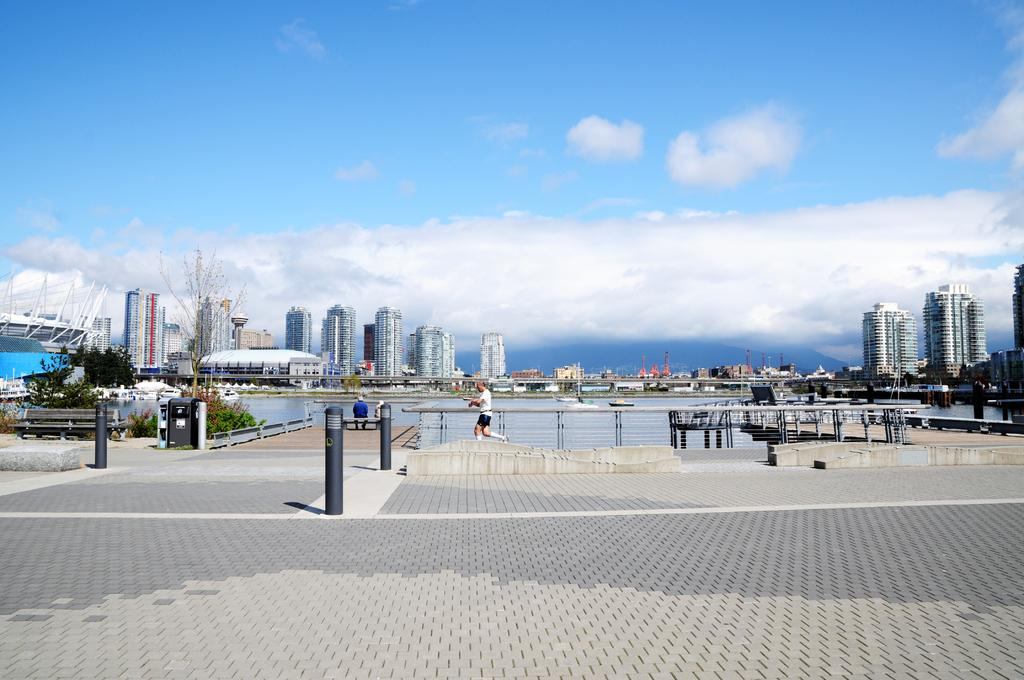What type of surface is in the front of the image? There are cobbler stones in the front of the image. What natural element is visible in the image? There is a river with water visible in the image. What can be seen in the background of the image? There are buildings in the background of the image. What is visible above the buildings and river? The sky is visible in the image. What can be observed in the sky? Clouds are present in the sky. What type of wrench is being used to fix the street in the image? There is no wrench present in the image, nor is there any indication of a street being fixed. 